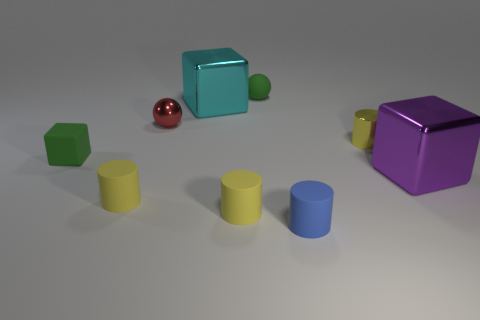What number of other things are the same color as the tiny cube?
Provide a succinct answer. 1. What size is the yellow matte thing that is on the left side of the large cyan object?
Offer a terse response. Small. There is a small object that is both to the left of the cyan shiny block and behind the small yellow metal thing; what color is it?
Offer a terse response. Red. Do the green object in front of the red shiny thing and the cyan metallic block have the same size?
Offer a very short reply. No. There is a shiny thing left of the cyan shiny object; are there any small yellow cylinders that are right of it?
Your answer should be very brief. Yes. What is the material of the tiny red sphere?
Your response must be concise. Metal. Are there any objects left of the tiny red thing?
Provide a succinct answer. Yes. There is a green matte thing that is the same shape as the purple thing; what size is it?
Offer a terse response. Small. Are there an equal number of yellow metallic cylinders in front of the small shiny cylinder and cubes behind the purple metallic thing?
Make the answer very short. No. What number of big gray cylinders are there?
Offer a terse response. 0. 